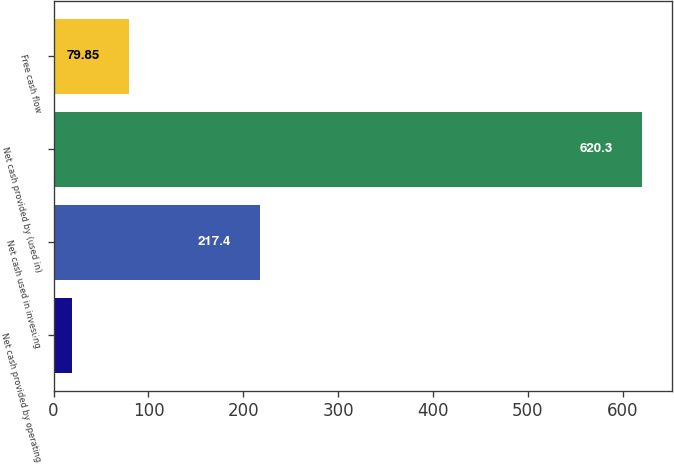Convert chart to OTSL. <chart><loc_0><loc_0><loc_500><loc_500><bar_chart><fcel>Net cash provided by operating<fcel>Net cash used in investing<fcel>Net cash provided by (used in)<fcel>Free cash flow<nl><fcel>19.8<fcel>217.4<fcel>620.3<fcel>79.85<nl></chart> 